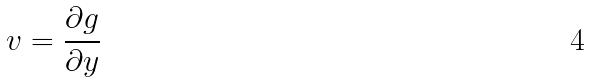<formula> <loc_0><loc_0><loc_500><loc_500>v = \frac { \partial g } { \partial y }</formula> 